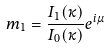Convert formula to latex. <formula><loc_0><loc_0><loc_500><loc_500>m _ { 1 } = \frac { I _ { 1 } ( \kappa ) } { I _ { 0 } ( \kappa ) } e ^ { i \mu }</formula> 